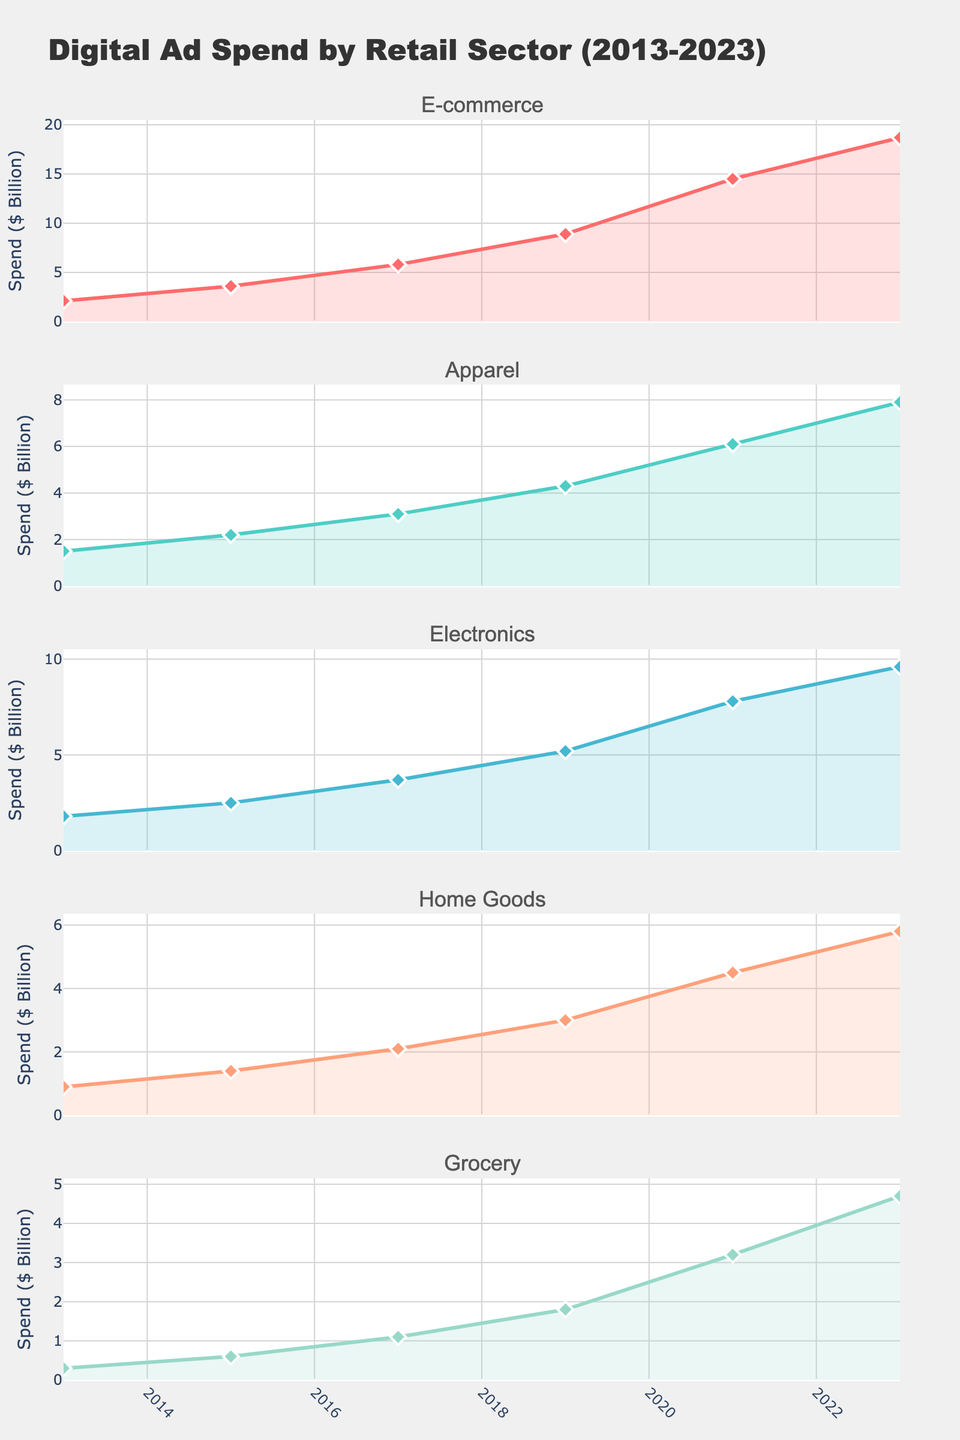What's the title of the figure? The title of the figure is typically located at the top of the visual. By reading it, we can understand the main topic or purpose of the figure.
Answer: Digital Ad Spend by Retail Sector (2013-2023) How many retail sectors are represented in the figure? By counting the subplot titles, which are indicated on the top of each subplot, we can determine the number of distinct retail sectors displayed.
Answer: 5 Which retail sector had the highest digital ad spend in 2023? We can identify this by looking at the y-axis values for each subplot and comparing the values at the year 2023.
Answer: E-commerce What was the digital ad spend for Home Goods in 2015? On the Home Goods subplot, locate the year 2015 on the x-axis and find the corresponding y-axis value.
Answer: 1.4 billion dollars Compare the digital ad spend growth of Electronics between 2013 and 2023. By observing the starting value in 2013 and the ending value in 2023 in the Electronics subplot, we can compute the growth by subtracting 2013's value from 2023's value.
Answer: 7.8 billion dollars Which sector showed the largest increase in digital ad spend between 2019 and 2021? Compare the rise in ad spend for all sectors between these years by checking the difference in y-axis values. The sector with the highest difference represents the largest increase.
Answer: E-commerce What is the average digital ad spend for Apparel over the entire period shown? Add up all the data points for Apparel from 2013 to 2023, then divide by the number of data points (6 years).
Answer: (1.5+2.2+3.1+4.3+6.1+7.9)/6 = 4.183 billion dollars In which year did Grocery saw the first significant rise in digital ad spend? On the Grocery subplot, identify the first substantial increase by comparing year-to-year changes and finding the initial large increment.
Answer: 2017 Is the digital ad spend trend for Home Goods linear over the decade? By examining the plot line in the Home Goods subplot, we can determine if it forms a straight line (indicative of a linear trend) or not.
Answer: No Which sector had the slowest growth in digital ad spend from 2013 to 2023? Compare the total growth for each sector over the decade and identify the one with the least increase in y-axis values.
Answer: Grocery 